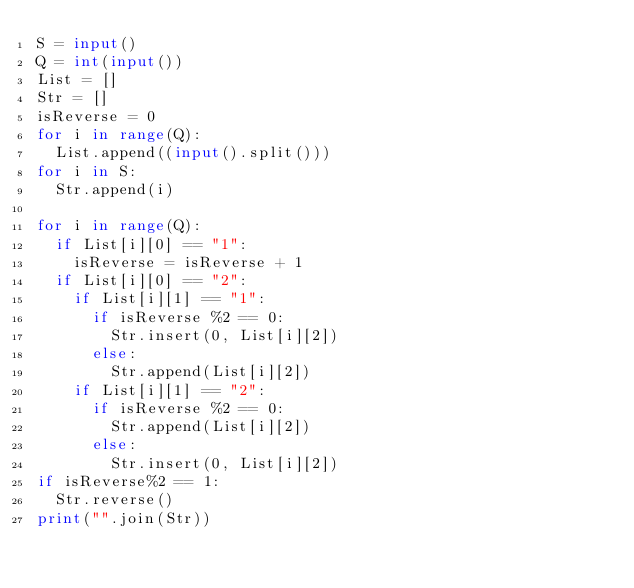Convert code to text. <code><loc_0><loc_0><loc_500><loc_500><_Python_>S = input()
Q = int(input())
List = []
Str = []
isReverse = 0
for i in range(Q):
  List.append((input().split()))
for i in S:
  Str.append(i)
  
for i in range(Q):
  if List[i][0] == "1":
    isReverse = isReverse + 1
  if List[i][0] == "2":
    if List[i][1] == "1":
      if isReverse %2 == 0:
        Str.insert(0, List[i][2])
      else:
        Str.append(List[i][2])
    if List[i][1] == "2":
      if isReverse %2 == 0:
        Str.append(List[i][2])
      else:
        Str.insert(0, List[i][2])
if isReverse%2 == 1:
  Str.reverse()
print("".join(Str))</code> 